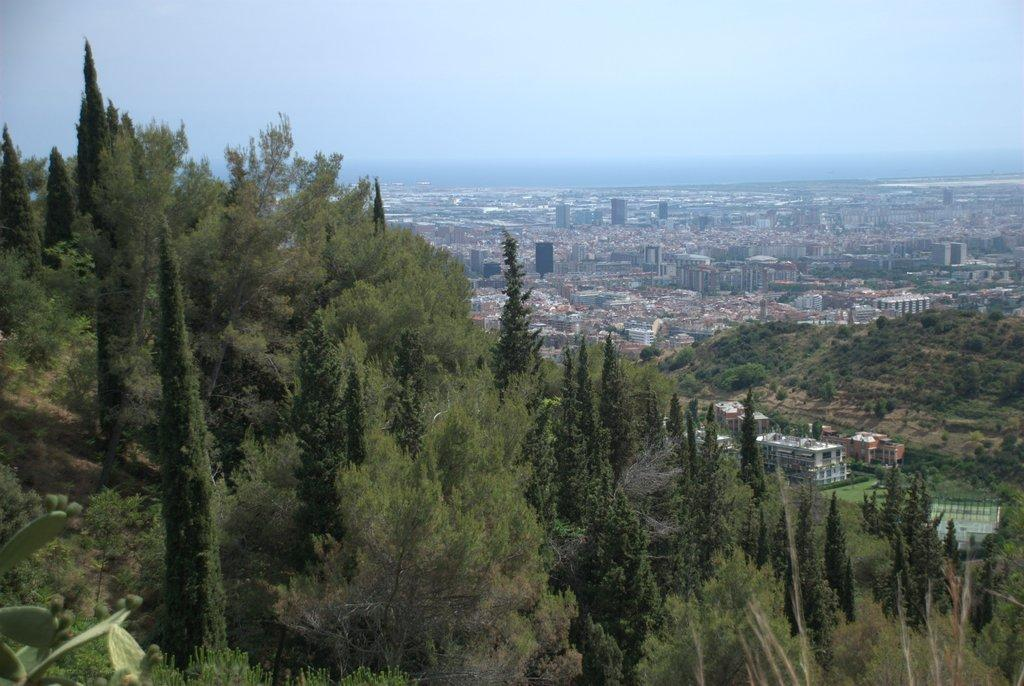What type of vegetation can be seen in the image? There are trees with leaves and branches in the image. What is the primary setting of the image? The image contains a view of the city. What type of structures are present in the image? There are buildings in the image, including skyscrapers. What type of can is visible in the image? There is no can present in the image; it features trees, a city view, and buildings. Is there a yard visible in the image? There is no yard visible in the image; it features trees, a city view, and buildings. 